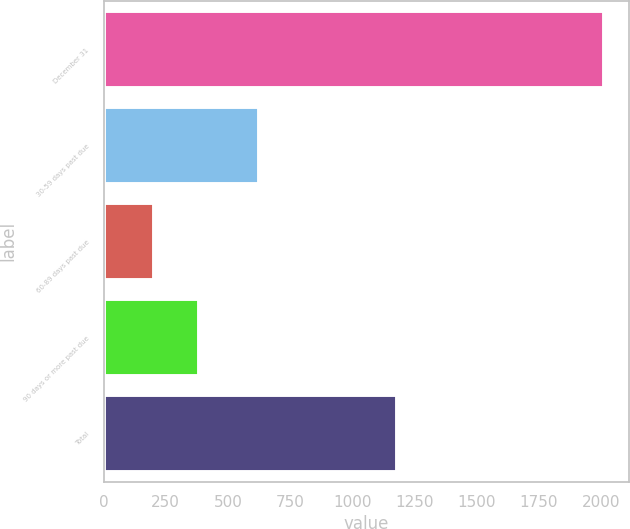Convert chart to OTSL. <chart><loc_0><loc_0><loc_500><loc_500><bar_chart><fcel>December 31<fcel>30-59 days past due<fcel>60-89 days past due<fcel>90 days or more past due<fcel>Total<nl><fcel>2014<fcel>626<fcel>201<fcel>382.3<fcel>1179<nl></chart> 